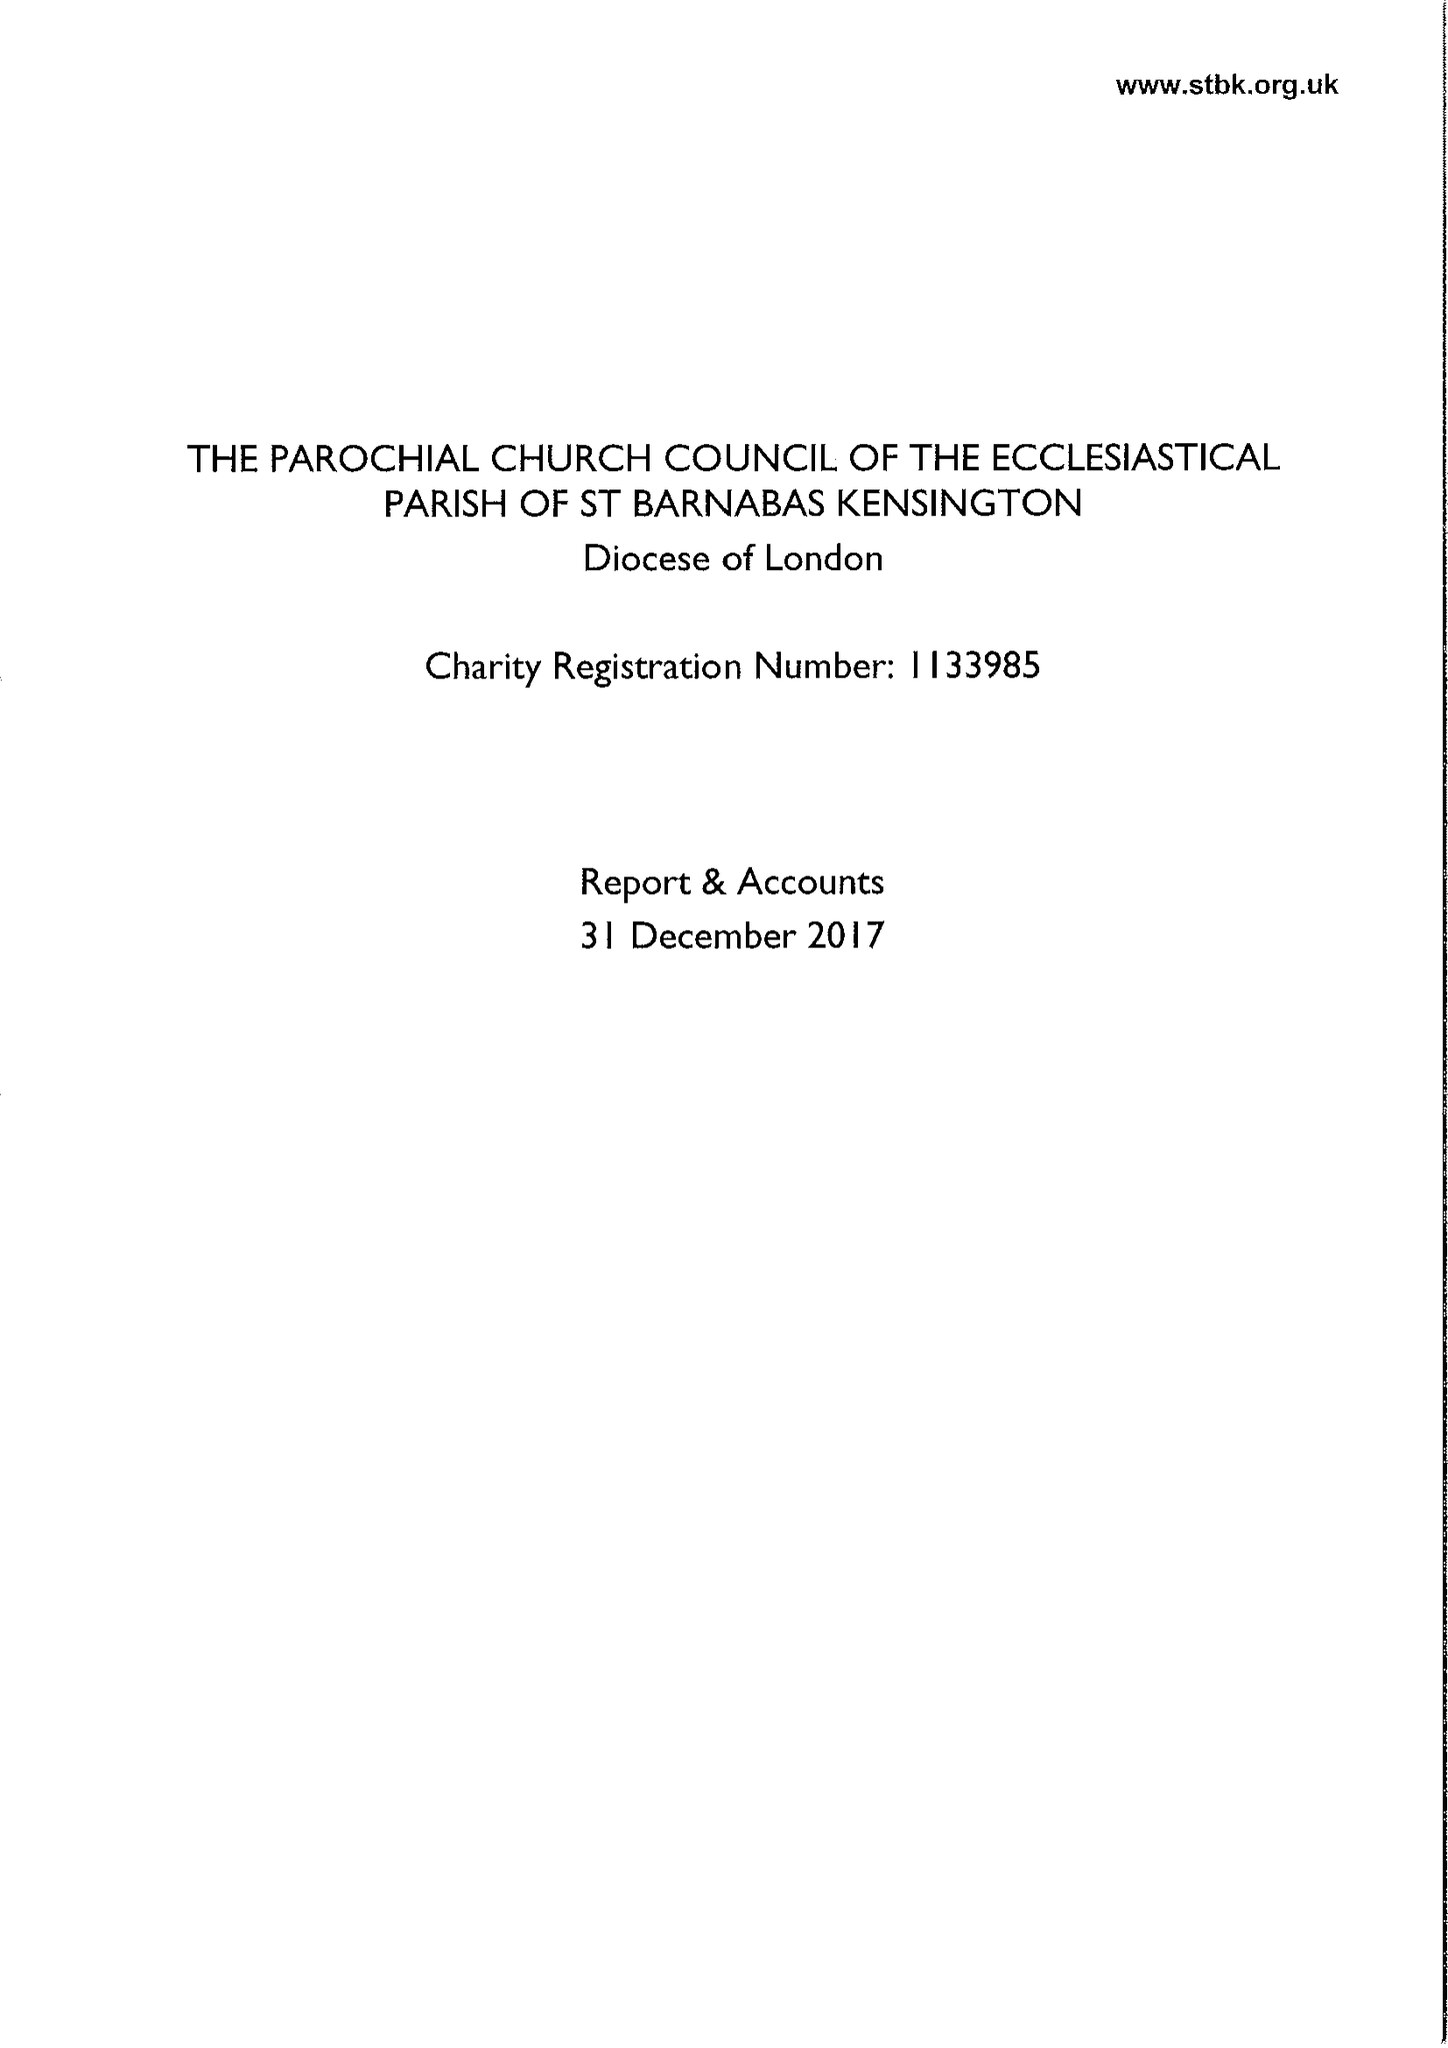What is the value for the address__post_town?
Answer the question using a single word or phrase. LONDON 